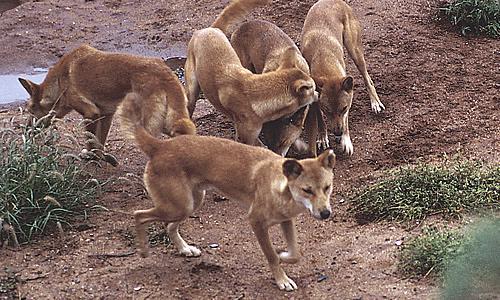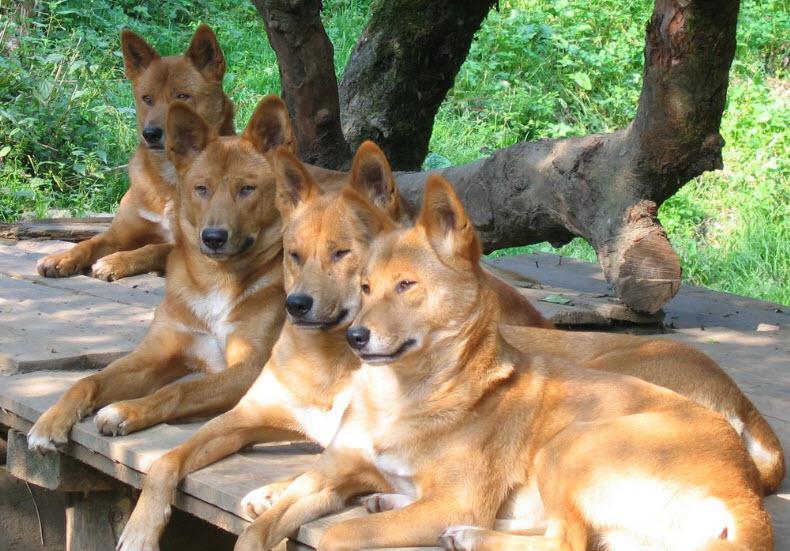The first image is the image on the left, the second image is the image on the right. Assess this claim about the two images: "The wild dog in the image on the right is standing on all fours.". Correct or not? Answer yes or no. No. The first image is the image on the left, the second image is the image on the right. Given the left and right images, does the statement "An image shows at least one dog standing by a carcass." hold true? Answer yes or no. No. 